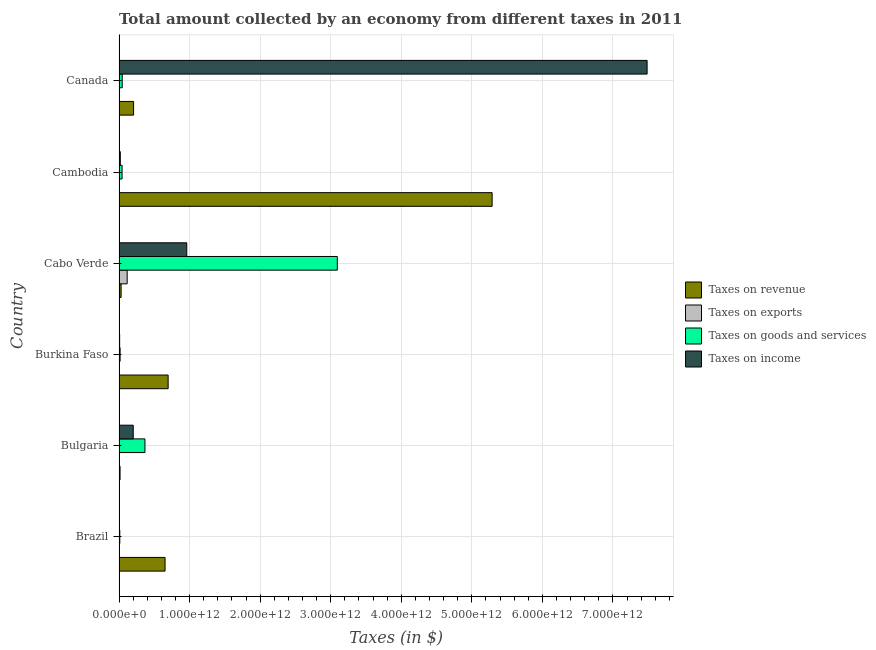How many different coloured bars are there?
Offer a terse response. 4. Are the number of bars on each tick of the Y-axis equal?
Keep it short and to the point. No. How many bars are there on the 2nd tick from the top?
Your response must be concise. 4. What is the label of the 4th group of bars from the top?
Offer a very short reply. Burkina Faso. What is the amount collected as tax on income in Bulgaria?
Your response must be concise. 2.01e+11. Across all countries, what is the maximum amount collected as tax on goods?
Give a very brief answer. 3.09e+12. Across all countries, what is the minimum amount collected as tax on goods?
Keep it short and to the point. 1.07e+1. In which country was the amount collected as tax on goods maximum?
Give a very brief answer. Cabo Verde. What is the total amount collected as tax on exports in the graph?
Keep it short and to the point. 1.18e+11. What is the difference between the amount collected as tax on exports in Bulgaria and that in Canada?
Provide a short and direct response. -7.51e+08. What is the difference between the amount collected as tax on revenue in Burkina Faso and the amount collected as tax on exports in Cabo Verde?
Ensure brevity in your answer.  5.81e+11. What is the average amount collected as tax on exports per country?
Your response must be concise. 1.97e+1. What is the difference between the amount collected as tax on income and amount collected as tax on revenue in Cabo Verde?
Offer a terse response. 9.30e+11. What is the ratio of the amount collected as tax on revenue in Brazil to that in Cambodia?
Offer a terse response. 0.12. Is the difference between the amount collected as tax on exports in Cabo Verde and Canada greater than the difference between the amount collected as tax on revenue in Cabo Verde and Canada?
Your response must be concise. Yes. What is the difference between the highest and the second highest amount collected as tax on revenue?
Offer a terse response. 4.59e+12. What is the difference between the highest and the lowest amount collected as tax on income?
Keep it short and to the point. 7.48e+12. In how many countries, is the amount collected as tax on revenue greater than the average amount collected as tax on revenue taken over all countries?
Your answer should be compact. 1. Is it the case that in every country, the sum of the amount collected as tax on revenue and amount collected as tax on exports is greater than the amount collected as tax on goods?
Your answer should be compact. No. How many bars are there?
Provide a succinct answer. 23. Are all the bars in the graph horizontal?
Keep it short and to the point. Yes. How many countries are there in the graph?
Give a very brief answer. 6. What is the difference between two consecutive major ticks on the X-axis?
Your answer should be compact. 1.00e+12. Are the values on the major ticks of X-axis written in scientific E-notation?
Give a very brief answer. Yes. Does the graph contain grids?
Make the answer very short. Yes. Where does the legend appear in the graph?
Keep it short and to the point. Center right. How many legend labels are there?
Ensure brevity in your answer.  4. How are the legend labels stacked?
Your response must be concise. Vertical. What is the title of the graph?
Your response must be concise. Total amount collected by an economy from different taxes in 2011. Does "Secondary vocational education" appear as one of the legend labels in the graph?
Your answer should be very brief. No. What is the label or title of the X-axis?
Make the answer very short. Taxes (in $). What is the Taxes (in $) of Taxes on revenue in Brazil?
Make the answer very short. 6.52e+11. What is the Taxes (in $) of Taxes on exports in Brazil?
Make the answer very short. 5.00e+06. What is the Taxes (in $) of Taxes on goods and services in Brazil?
Offer a very short reply. 1.07e+1. What is the Taxes (in $) in Taxes on income in Brazil?
Provide a short and direct response. 3.66e+09. What is the Taxes (in $) in Taxes on revenue in Bulgaria?
Give a very brief answer. 1.43e+1. What is the Taxes (in $) of Taxes on exports in Bulgaria?
Offer a terse response. 1.33e+09. What is the Taxes (in $) in Taxes on goods and services in Bulgaria?
Provide a succinct answer. 3.67e+11. What is the Taxes (in $) of Taxes on income in Bulgaria?
Your response must be concise. 2.01e+11. What is the Taxes (in $) of Taxes on revenue in Burkina Faso?
Offer a terse response. 6.96e+11. What is the Taxes (in $) in Taxes on exports in Burkina Faso?
Your answer should be very brief. 0. What is the Taxes (in $) in Taxes on goods and services in Burkina Faso?
Make the answer very short. 1.50e+1. What is the Taxes (in $) of Taxes on income in Burkina Faso?
Your answer should be very brief. 8.28e+09. What is the Taxes (in $) of Taxes on revenue in Cabo Verde?
Your answer should be very brief. 2.92e+1. What is the Taxes (in $) of Taxes on exports in Cabo Verde?
Ensure brevity in your answer.  1.15e+11. What is the Taxes (in $) in Taxes on goods and services in Cabo Verde?
Make the answer very short. 3.09e+12. What is the Taxes (in $) of Taxes on income in Cabo Verde?
Provide a short and direct response. 9.60e+11. What is the Taxes (in $) of Taxes on revenue in Cambodia?
Offer a terse response. 5.29e+12. What is the Taxes (in $) in Taxes on exports in Cambodia?
Ensure brevity in your answer.  2.67e+04. What is the Taxes (in $) in Taxes on goods and services in Cambodia?
Ensure brevity in your answer.  4.28e+1. What is the Taxes (in $) in Taxes on income in Cambodia?
Provide a short and direct response. 1.77e+1. What is the Taxes (in $) of Taxes on revenue in Canada?
Your answer should be very brief. 2.06e+11. What is the Taxes (in $) of Taxes on exports in Canada?
Offer a terse response. 2.08e+09. What is the Taxes (in $) of Taxes on goods and services in Canada?
Make the answer very short. 4.49e+1. What is the Taxes (in $) in Taxes on income in Canada?
Your answer should be compact. 7.48e+12. Across all countries, what is the maximum Taxes (in $) of Taxes on revenue?
Ensure brevity in your answer.  5.29e+12. Across all countries, what is the maximum Taxes (in $) of Taxes on exports?
Offer a very short reply. 1.15e+11. Across all countries, what is the maximum Taxes (in $) in Taxes on goods and services?
Your response must be concise. 3.09e+12. Across all countries, what is the maximum Taxes (in $) of Taxes on income?
Keep it short and to the point. 7.48e+12. Across all countries, what is the minimum Taxes (in $) in Taxes on revenue?
Your answer should be very brief. 1.43e+1. Across all countries, what is the minimum Taxes (in $) of Taxes on goods and services?
Your answer should be compact. 1.07e+1. Across all countries, what is the minimum Taxes (in $) of Taxes on income?
Make the answer very short. 3.66e+09. What is the total Taxes (in $) in Taxes on revenue in the graph?
Offer a terse response. 6.88e+12. What is the total Taxes (in $) of Taxes on exports in the graph?
Provide a succinct answer. 1.18e+11. What is the total Taxes (in $) of Taxes on goods and services in the graph?
Offer a very short reply. 3.57e+12. What is the total Taxes (in $) of Taxes on income in the graph?
Offer a very short reply. 8.67e+12. What is the difference between the Taxes (in $) in Taxes on revenue in Brazil and that in Bulgaria?
Keep it short and to the point. 6.38e+11. What is the difference between the Taxes (in $) in Taxes on exports in Brazil and that in Bulgaria?
Your answer should be compact. -1.32e+09. What is the difference between the Taxes (in $) in Taxes on goods and services in Brazil and that in Bulgaria?
Your answer should be very brief. -3.56e+11. What is the difference between the Taxes (in $) in Taxes on income in Brazil and that in Bulgaria?
Your response must be concise. -1.97e+11. What is the difference between the Taxes (in $) of Taxes on revenue in Brazil and that in Burkina Faso?
Offer a very short reply. -4.36e+1. What is the difference between the Taxes (in $) of Taxes on goods and services in Brazil and that in Burkina Faso?
Your response must be concise. -4.31e+09. What is the difference between the Taxes (in $) of Taxes on income in Brazil and that in Burkina Faso?
Offer a terse response. -4.63e+09. What is the difference between the Taxes (in $) of Taxes on revenue in Brazil and that in Cabo Verde?
Offer a terse response. 6.23e+11. What is the difference between the Taxes (in $) of Taxes on exports in Brazil and that in Cabo Verde?
Your answer should be compact. -1.15e+11. What is the difference between the Taxes (in $) of Taxes on goods and services in Brazil and that in Cabo Verde?
Your answer should be very brief. -3.08e+12. What is the difference between the Taxes (in $) of Taxes on income in Brazil and that in Cabo Verde?
Make the answer very short. -9.56e+11. What is the difference between the Taxes (in $) in Taxes on revenue in Brazil and that in Cambodia?
Ensure brevity in your answer.  -4.64e+12. What is the difference between the Taxes (in $) in Taxes on exports in Brazil and that in Cambodia?
Make the answer very short. 4.97e+06. What is the difference between the Taxes (in $) in Taxes on goods and services in Brazil and that in Cambodia?
Make the answer very short. -3.22e+1. What is the difference between the Taxes (in $) in Taxes on income in Brazil and that in Cambodia?
Your answer should be very brief. -1.40e+1. What is the difference between the Taxes (in $) in Taxes on revenue in Brazil and that in Canada?
Ensure brevity in your answer.  4.46e+11. What is the difference between the Taxes (in $) in Taxes on exports in Brazil and that in Canada?
Your answer should be very brief. -2.08e+09. What is the difference between the Taxes (in $) of Taxes on goods and services in Brazil and that in Canada?
Make the answer very short. -3.42e+1. What is the difference between the Taxes (in $) in Taxes on income in Brazil and that in Canada?
Ensure brevity in your answer.  -7.48e+12. What is the difference between the Taxes (in $) in Taxes on revenue in Bulgaria and that in Burkina Faso?
Offer a very short reply. -6.81e+11. What is the difference between the Taxes (in $) in Taxes on goods and services in Bulgaria and that in Burkina Faso?
Your answer should be very brief. 3.52e+11. What is the difference between the Taxes (in $) in Taxes on income in Bulgaria and that in Burkina Faso?
Provide a succinct answer. 1.93e+11. What is the difference between the Taxes (in $) in Taxes on revenue in Bulgaria and that in Cabo Verde?
Provide a succinct answer. -1.48e+1. What is the difference between the Taxes (in $) of Taxes on exports in Bulgaria and that in Cabo Verde?
Your answer should be compact. -1.14e+11. What is the difference between the Taxes (in $) of Taxes on goods and services in Bulgaria and that in Cabo Verde?
Your answer should be compact. -2.73e+12. What is the difference between the Taxes (in $) of Taxes on income in Bulgaria and that in Cabo Verde?
Provide a short and direct response. -7.59e+11. What is the difference between the Taxes (in $) of Taxes on revenue in Bulgaria and that in Cambodia?
Keep it short and to the point. -5.27e+12. What is the difference between the Taxes (in $) of Taxes on exports in Bulgaria and that in Cambodia?
Provide a succinct answer. 1.33e+09. What is the difference between the Taxes (in $) of Taxes on goods and services in Bulgaria and that in Cambodia?
Provide a short and direct response. 3.24e+11. What is the difference between the Taxes (in $) in Taxes on income in Bulgaria and that in Cambodia?
Make the answer very short. 1.83e+11. What is the difference between the Taxes (in $) of Taxes on revenue in Bulgaria and that in Canada?
Give a very brief answer. -1.92e+11. What is the difference between the Taxes (in $) of Taxes on exports in Bulgaria and that in Canada?
Your answer should be very brief. -7.51e+08. What is the difference between the Taxes (in $) of Taxes on goods and services in Bulgaria and that in Canada?
Provide a succinct answer. 3.22e+11. What is the difference between the Taxes (in $) in Taxes on income in Bulgaria and that in Canada?
Your answer should be compact. -7.28e+12. What is the difference between the Taxes (in $) in Taxes on revenue in Burkina Faso and that in Cabo Verde?
Ensure brevity in your answer.  6.66e+11. What is the difference between the Taxes (in $) in Taxes on goods and services in Burkina Faso and that in Cabo Verde?
Make the answer very short. -3.08e+12. What is the difference between the Taxes (in $) in Taxes on income in Burkina Faso and that in Cabo Verde?
Provide a short and direct response. -9.51e+11. What is the difference between the Taxes (in $) of Taxes on revenue in Burkina Faso and that in Cambodia?
Give a very brief answer. -4.59e+12. What is the difference between the Taxes (in $) of Taxes on goods and services in Burkina Faso and that in Cambodia?
Provide a succinct answer. -2.79e+1. What is the difference between the Taxes (in $) of Taxes on income in Burkina Faso and that in Cambodia?
Your answer should be compact. -9.39e+09. What is the difference between the Taxes (in $) of Taxes on revenue in Burkina Faso and that in Canada?
Keep it short and to the point. 4.89e+11. What is the difference between the Taxes (in $) of Taxes on goods and services in Burkina Faso and that in Canada?
Give a very brief answer. -2.99e+1. What is the difference between the Taxes (in $) in Taxes on income in Burkina Faso and that in Canada?
Offer a terse response. -7.48e+12. What is the difference between the Taxes (in $) of Taxes on revenue in Cabo Verde and that in Cambodia?
Your answer should be compact. -5.26e+12. What is the difference between the Taxes (in $) in Taxes on exports in Cabo Verde and that in Cambodia?
Give a very brief answer. 1.15e+11. What is the difference between the Taxes (in $) of Taxes on goods and services in Cabo Verde and that in Cambodia?
Your answer should be very brief. 3.05e+12. What is the difference between the Taxes (in $) in Taxes on income in Cabo Verde and that in Cambodia?
Keep it short and to the point. 9.42e+11. What is the difference between the Taxes (in $) in Taxes on revenue in Cabo Verde and that in Canada?
Your response must be concise. -1.77e+11. What is the difference between the Taxes (in $) in Taxes on exports in Cabo Verde and that in Canada?
Provide a succinct answer. 1.13e+11. What is the difference between the Taxes (in $) of Taxes on goods and services in Cabo Verde and that in Canada?
Your answer should be compact. 3.05e+12. What is the difference between the Taxes (in $) in Taxes on income in Cabo Verde and that in Canada?
Keep it short and to the point. -6.52e+12. What is the difference between the Taxes (in $) in Taxes on revenue in Cambodia and that in Canada?
Give a very brief answer. 5.08e+12. What is the difference between the Taxes (in $) of Taxes on exports in Cambodia and that in Canada?
Provide a short and direct response. -2.08e+09. What is the difference between the Taxes (in $) of Taxes on goods and services in Cambodia and that in Canada?
Your answer should be compact. -2.03e+09. What is the difference between the Taxes (in $) in Taxes on income in Cambodia and that in Canada?
Offer a terse response. -7.47e+12. What is the difference between the Taxes (in $) of Taxes on revenue in Brazil and the Taxes (in $) of Taxes on exports in Bulgaria?
Ensure brevity in your answer.  6.51e+11. What is the difference between the Taxes (in $) of Taxes on revenue in Brazil and the Taxes (in $) of Taxes on goods and services in Bulgaria?
Your answer should be very brief. 2.85e+11. What is the difference between the Taxes (in $) of Taxes on revenue in Brazil and the Taxes (in $) of Taxes on income in Bulgaria?
Provide a short and direct response. 4.51e+11. What is the difference between the Taxes (in $) in Taxes on exports in Brazil and the Taxes (in $) in Taxes on goods and services in Bulgaria?
Offer a very short reply. -3.67e+11. What is the difference between the Taxes (in $) in Taxes on exports in Brazil and the Taxes (in $) in Taxes on income in Bulgaria?
Your answer should be compact. -2.01e+11. What is the difference between the Taxes (in $) of Taxes on goods and services in Brazil and the Taxes (in $) of Taxes on income in Bulgaria?
Ensure brevity in your answer.  -1.90e+11. What is the difference between the Taxes (in $) of Taxes on revenue in Brazil and the Taxes (in $) of Taxes on goods and services in Burkina Faso?
Offer a very short reply. 6.37e+11. What is the difference between the Taxes (in $) of Taxes on revenue in Brazil and the Taxes (in $) of Taxes on income in Burkina Faso?
Give a very brief answer. 6.44e+11. What is the difference between the Taxes (in $) of Taxes on exports in Brazil and the Taxes (in $) of Taxes on goods and services in Burkina Faso?
Offer a terse response. -1.50e+1. What is the difference between the Taxes (in $) of Taxes on exports in Brazil and the Taxes (in $) of Taxes on income in Burkina Faso?
Your response must be concise. -8.28e+09. What is the difference between the Taxes (in $) in Taxes on goods and services in Brazil and the Taxes (in $) in Taxes on income in Burkina Faso?
Keep it short and to the point. 2.37e+09. What is the difference between the Taxes (in $) in Taxes on revenue in Brazil and the Taxes (in $) in Taxes on exports in Cabo Verde?
Your answer should be compact. 5.37e+11. What is the difference between the Taxes (in $) of Taxes on revenue in Brazil and the Taxes (in $) of Taxes on goods and services in Cabo Verde?
Make the answer very short. -2.44e+12. What is the difference between the Taxes (in $) in Taxes on revenue in Brazil and the Taxes (in $) in Taxes on income in Cabo Verde?
Your answer should be compact. -3.08e+11. What is the difference between the Taxes (in $) of Taxes on exports in Brazil and the Taxes (in $) of Taxes on goods and services in Cabo Verde?
Your answer should be compact. -3.09e+12. What is the difference between the Taxes (in $) of Taxes on exports in Brazil and the Taxes (in $) of Taxes on income in Cabo Verde?
Your response must be concise. -9.60e+11. What is the difference between the Taxes (in $) in Taxes on goods and services in Brazil and the Taxes (in $) in Taxes on income in Cabo Verde?
Your answer should be compact. -9.49e+11. What is the difference between the Taxes (in $) of Taxes on revenue in Brazil and the Taxes (in $) of Taxes on exports in Cambodia?
Offer a terse response. 6.52e+11. What is the difference between the Taxes (in $) of Taxes on revenue in Brazil and the Taxes (in $) of Taxes on goods and services in Cambodia?
Ensure brevity in your answer.  6.09e+11. What is the difference between the Taxes (in $) of Taxes on revenue in Brazil and the Taxes (in $) of Taxes on income in Cambodia?
Provide a succinct answer. 6.34e+11. What is the difference between the Taxes (in $) in Taxes on exports in Brazil and the Taxes (in $) in Taxes on goods and services in Cambodia?
Offer a terse response. -4.28e+1. What is the difference between the Taxes (in $) of Taxes on exports in Brazil and the Taxes (in $) of Taxes on income in Cambodia?
Make the answer very short. -1.77e+1. What is the difference between the Taxes (in $) in Taxes on goods and services in Brazil and the Taxes (in $) in Taxes on income in Cambodia?
Your answer should be very brief. -7.03e+09. What is the difference between the Taxes (in $) of Taxes on revenue in Brazil and the Taxes (in $) of Taxes on exports in Canada?
Make the answer very short. 6.50e+11. What is the difference between the Taxes (in $) in Taxes on revenue in Brazil and the Taxes (in $) in Taxes on goods and services in Canada?
Offer a very short reply. 6.07e+11. What is the difference between the Taxes (in $) of Taxes on revenue in Brazil and the Taxes (in $) of Taxes on income in Canada?
Ensure brevity in your answer.  -6.83e+12. What is the difference between the Taxes (in $) in Taxes on exports in Brazil and the Taxes (in $) in Taxes on goods and services in Canada?
Offer a very short reply. -4.49e+1. What is the difference between the Taxes (in $) in Taxes on exports in Brazil and the Taxes (in $) in Taxes on income in Canada?
Make the answer very short. -7.48e+12. What is the difference between the Taxes (in $) in Taxes on goods and services in Brazil and the Taxes (in $) in Taxes on income in Canada?
Offer a terse response. -7.47e+12. What is the difference between the Taxes (in $) of Taxes on revenue in Bulgaria and the Taxes (in $) of Taxes on goods and services in Burkina Faso?
Your answer should be compact. -6.16e+08. What is the difference between the Taxes (in $) of Taxes on revenue in Bulgaria and the Taxes (in $) of Taxes on income in Burkina Faso?
Make the answer very short. 6.06e+09. What is the difference between the Taxes (in $) of Taxes on exports in Bulgaria and the Taxes (in $) of Taxes on goods and services in Burkina Faso?
Offer a terse response. -1.36e+1. What is the difference between the Taxes (in $) in Taxes on exports in Bulgaria and the Taxes (in $) in Taxes on income in Burkina Faso?
Your answer should be very brief. -6.95e+09. What is the difference between the Taxes (in $) of Taxes on goods and services in Bulgaria and the Taxes (in $) of Taxes on income in Burkina Faso?
Offer a terse response. 3.58e+11. What is the difference between the Taxes (in $) of Taxes on revenue in Bulgaria and the Taxes (in $) of Taxes on exports in Cabo Verde?
Your response must be concise. -1.01e+11. What is the difference between the Taxes (in $) in Taxes on revenue in Bulgaria and the Taxes (in $) in Taxes on goods and services in Cabo Verde?
Provide a short and direct response. -3.08e+12. What is the difference between the Taxes (in $) of Taxes on revenue in Bulgaria and the Taxes (in $) of Taxes on income in Cabo Verde?
Provide a short and direct response. -9.45e+11. What is the difference between the Taxes (in $) of Taxes on exports in Bulgaria and the Taxes (in $) of Taxes on goods and services in Cabo Verde?
Ensure brevity in your answer.  -3.09e+12. What is the difference between the Taxes (in $) of Taxes on exports in Bulgaria and the Taxes (in $) of Taxes on income in Cabo Verde?
Keep it short and to the point. -9.58e+11. What is the difference between the Taxes (in $) of Taxes on goods and services in Bulgaria and the Taxes (in $) of Taxes on income in Cabo Verde?
Keep it short and to the point. -5.93e+11. What is the difference between the Taxes (in $) of Taxes on revenue in Bulgaria and the Taxes (in $) of Taxes on exports in Cambodia?
Provide a short and direct response. 1.43e+1. What is the difference between the Taxes (in $) of Taxes on revenue in Bulgaria and the Taxes (in $) of Taxes on goods and services in Cambodia?
Provide a succinct answer. -2.85e+1. What is the difference between the Taxes (in $) in Taxes on revenue in Bulgaria and the Taxes (in $) in Taxes on income in Cambodia?
Your response must be concise. -3.33e+09. What is the difference between the Taxes (in $) of Taxes on exports in Bulgaria and the Taxes (in $) of Taxes on goods and services in Cambodia?
Your response must be concise. -4.15e+1. What is the difference between the Taxes (in $) of Taxes on exports in Bulgaria and the Taxes (in $) of Taxes on income in Cambodia?
Provide a succinct answer. -1.63e+1. What is the difference between the Taxes (in $) in Taxes on goods and services in Bulgaria and the Taxes (in $) in Taxes on income in Cambodia?
Ensure brevity in your answer.  3.49e+11. What is the difference between the Taxes (in $) in Taxes on revenue in Bulgaria and the Taxes (in $) in Taxes on exports in Canada?
Offer a very short reply. 1.23e+1. What is the difference between the Taxes (in $) in Taxes on revenue in Bulgaria and the Taxes (in $) in Taxes on goods and services in Canada?
Keep it short and to the point. -3.05e+1. What is the difference between the Taxes (in $) in Taxes on revenue in Bulgaria and the Taxes (in $) in Taxes on income in Canada?
Make the answer very short. -7.47e+12. What is the difference between the Taxes (in $) of Taxes on exports in Bulgaria and the Taxes (in $) of Taxes on goods and services in Canada?
Offer a terse response. -4.35e+1. What is the difference between the Taxes (in $) of Taxes on exports in Bulgaria and the Taxes (in $) of Taxes on income in Canada?
Your answer should be compact. -7.48e+12. What is the difference between the Taxes (in $) in Taxes on goods and services in Bulgaria and the Taxes (in $) in Taxes on income in Canada?
Your answer should be very brief. -7.12e+12. What is the difference between the Taxes (in $) of Taxes on revenue in Burkina Faso and the Taxes (in $) of Taxes on exports in Cabo Verde?
Make the answer very short. 5.81e+11. What is the difference between the Taxes (in $) of Taxes on revenue in Burkina Faso and the Taxes (in $) of Taxes on goods and services in Cabo Verde?
Your answer should be very brief. -2.40e+12. What is the difference between the Taxes (in $) of Taxes on revenue in Burkina Faso and the Taxes (in $) of Taxes on income in Cabo Verde?
Offer a terse response. -2.64e+11. What is the difference between the Taxes (in $) of Taxes on goods and services in Burkina Faso and the Taxes (in $) of Taxes on income in Cabo Verde?
Offer a terse response. -9.45e+11. What is the difference between the Taxes (in $) in Taxes on revenue in Burkina Faso and the Taxes (in $) in Taxes on exports in Cambodia?
Make the answer very short. 6.96e+11. What is the difference between the Taxes (in $) of Taxes on revenue in Burkina Faso and the Taxes (in $) of Taxes on goods and services in Cambodia?
Make the answer very short. 6.53e+11. What is the difference between the Taxes (in $) in Taxes on revenue in Burkina Faso and the Taxes (in $) in Taxes on income in Cambodia?
Offer a terse response. 6.78e+11. What is the difference between the Taxes (in $) of Taxes on goods and services in Burkina Faso and the Taxes (in $) of Taxes on income in Cambodia?
Give a very brief answer. -2.71e+09. What is the difference between the Taxes (in $) of Taxes on revenue in Burkina Faso and the Taxes (in $) of Taxes on exports in Canada?
Give a very brief answer. 6.94e+11. What is the difference between the Taxes (in $) of Taxes on revenue in Burkina Faso and the Taxes (in $) of Taxes on goods and services in Canada?
Provide a short and direct response. 6.51e+11. What is the difference between the Taxes (in $) of Taxes on revenue in Burkina Faso and the Taxes (in $) of Taxes on income in Canada?
Your answer should be very brief. -6.79e+12. What is the difference between the Taxes (in $) of Taxes on goods and services in Burkina Faso and the Taxes (in $) of Taxes on income in Canada?
Ensure brevity in your answer.  -7.47e+12. What is the difference between the Taxes (in $) of Taxes on revenue in Cabo Verde and the Taxes (in $) of Taxes on exports in Cambodia?
Offer a terse response. 2.92e+1. What is the difference between the Taxes (in $) of Taxes on revenue in Cabo Verde and the Taxes (in $) of Taxes on goods and services in Cambodia?
Provide a short and direct response. -1.37e+1. What is the difference between the Taxes (in $) in Taxes on revenue in Cabo Verde and the Taxes (in $) in Taxes on income in Cambodia?
Make the answer very short. 1.15e+1. What is the difference between the Taxes (in $) of Taxes on exports in Cabo Verde and the Taxes (in $) of Taxes on goods and services in Cambodia?
Your response must be concise. 7.22e+1. What is the difference between the Taxes (in $) of Taxes on exports in Cabo Verde and the Taxes (in $) of Taxes on income in Cambodia?
Provide a succinct answer. 9.74e+1. What is the difference between the Taxes (in $) of Taxes on goods and services in Cabo Verde and the Taxes (in $) of Taxes on income in Cambodia?
Your answer should be very brief. 3.08e+12. What is the difference between the Taxes (in $) of Taxes on revenue in Cabo Verde and the Taxes (in $) of Taxes on exports in Canada?
Ensure brevity in your answer.  2.71e+1. What is the difference between the Taxes (in $) of Taxes on revenue in Cabo Verde and the Taxes (in $) of Taxes on goods and services in Canada?
Make the answer very short. -1.57e+1. What is the difference between the Taxes (in $) of Taxes on revenue in Cabo Verde and the Taxes (in $) of Taxes on income in Canada?
Keep it short and to the point. -7.45e+12. What is the difference between the Taxes (in $) in Taxes on exports in Cabo Verde and the Taxes (in $) in Taxes on goods and services in Canada?
Provide a short and direct response. 7.02e+1. What is the difference between the Taxes (in $) of Taxes on exports in Cabo Verde and the Taxes (in $) of Taxes on income in Canada?
Offer a terse response. -7.37e+12. What is the difference between the Taxes (in $) of Taxes on goods and services in Cabo Verde and the Taxes (in $) of Taxes on income in Canada?
Your answer should be very brief. -4.39e+12. What is the difference between the Taxes (in $) of Taxes on revenue in Cambodia and the Taxes (in $) of Taxes on exports in Canada?
Give a very brief answer. 5.29e+12. What is the difference between the Taxes (in $) in Taxes on revenue in Cambodia and the Taxes (in $) in Taxes on goods and services in Canada?
Your response must be concise. 5.24e+12. What is the difference between the Taxes (in $) in Taxes on revenue in Cambodia and the Taxes (in $) in Taxes on income in Canada?
Give a very brief answer. -2.20e+12. What is the difference between the Taxes (in $) in Taxes on exports in Cambodia and the Taxes (in $) in Taxes on goods and services in Canada?
Provide a succinct answer. -4.49e+1. What is the difference between the Taxes (in $) in Taxes on exports in Cambodia and the Taxes (in $) in Taxes on income in Canada?
Your answer should be compact. -7.48e+12. What is the difference between the Taxes (in $) in Taxes on goods and services in Cambodia and the Taxes (in $) in Taxes on income in Canada?
Your answer should be very brief. -7.44e+12. What is the average Taxes (in $) of Taxes on revenue per country?
Your answer should be compact. 1.15e+12. What is the average Taxes (in $) of Taxes on exports per country?
Your response must be concise. 1.97e+1. What is the average Taxes (in $) in Taxes on goods and services per country?
Your answer should be very brief. 5.96e+11. What is the average Taxes (in $) in Taxes on income per country?
Your response must be concise. 1.45e+12. What is the difference between the Taxes (in $) of Taxes on revenue and Taxes (in $) of Taxes on exports in Brazil?
Your response must be concise. 6.52e+11. What is the difference between the Taxes (in $) in Taxes on revenue and Taxes (in $) in Taxes on goods and services in Brazil?
Your answer should be very brief. 6.41e+11. What is the difference between the Taxes (in $) in Taxes on revenue and Taxes (in $) in Taxes on income in Brazil?
Offer a terse response. 6.48e+11. What is the difference between the Taxes (in $) in Taxes on exports and Taxes (in $) in Taxes on goods and services in Brazil?
Your answer should be very brief. -1.06e+1. What is the difference between the Taxes (in $) of Taxes on exports and Taxes (in $) of Taxes on income in Brazil?
Give a very brief answer. -3.65e+09. What is the difference between the Taxes (in $) in Taxes on goods and services and Taxes (in $) in Taxes on income in Brazil?
Provide a succinct answer. 6.99e+09. What is the difference between the Taxes (in $) of Taxes on revenue and Taxes (in $) of Taxes on exports in Bulgaria?
Your answer should be very brief. 1.30e+1. What is the difference between the Taxes (in $) of Taxes on revenue and Taxes (in $) of Taxes on goods and services in Bulgaria?
Ensure brevity in your answer.  -3.52e+11. What is the difference between the Taxes (in $) in Taxes on revenue and Taxes (in $) in Taxes on income in Bulgaria?
Give a very brief answer. -1.87e+11. What is the difference between the Taxes (in $) of Taxes on exports and Taxes (in $) of Taxes on goods and services in Bulgaria?
Your answer should be very brief. -3.65e+11. What is the difference between the Taxes (in $) in Taxes on exports and Taxes (in $) in Taxes on income in Bulgaria?
Ensure brevity in your answer.  -2.00e+11. What is the difference between the Taxes (in $) in Taxes on goods and services and Taxes (in $) in Taxes on income in Bulgaria?
Ensure brevity in your answer.  1.66e+11. What is the difference between the Taxes (in $) in Taxes on revenue and Taxes (in $) in Taxes on goods and services in Burkina Faso?
Offer a very short reply. 6.81e+11. What is the difference between the Taxes (in $) in Taxes on revenue and Taxes (in $) in Taxes on income in Burkina Faso?
Your answer should be compact. 6.87e+11. What is the difference between the Taxes (in $) in Taxes on goods and services and Taxes (in $) in Taxes on income in Burkina Faso?
Your response must be concise. 6.68e+09. What is the difference between the Taxes (in $) of Taxes on revenue and Taxes (in $) of Taxes on exports in Cabo Verde?
Ensure brevity in your answer.  -8.59e+1. What is the difference between the Taxes (in $) in Taxes on revenue and Taxes (in $) in Taxes on goods and services in Cabo Verde?
Offer a very short reply. -3.06e+12. What is the difference between the Taxes (in $) in Taxes on revenue and Taxes (in $) in Taxes on income in Cabo Verde?
Keep it short and to the point. -9.30e+11. What is the difference between the Taxes (in $) of Taxes on exports and Taxes (in $) of Taxes on goods and services in Cabo Verde?
Give a very brief answer. -2.98e+12. What is the difference between the Taxes (in $) in Taxes on exports and Taxes (in $) in Taxes on income in Cabo Verde?
Provide a short and direct response. -8.45e+11. What is the difference between the Taxes (in $) in Taxes on goods and services and Taxes (in $) in Taxes on income in Cabo Verde?
Offer a terse response. 2.13e+12. What is the difference between the Taxes (in $) of Taxes on revenue and Taxes (in $) of Taxes on exports in Cambodia?
Ensure brevity in your answer.  5.29e+12. What is the difference between the Taxes (in $) of Taxes on revenue and Taxes (in $) of Taxes on goods and services in Cambodia?
Offer a terse response. 5.24e+12. What is the difference between the Taxes (in $) of Taxes on revenue and Taxes (in $) of Taxes on income in Cambodia?
Provide a short and direct response. 5.27e+12. What is the difference between the Taxes (in $) of Taxes on exports and Taxes (in $) of Taxes on goods and services in Cambodia?
Give a very brief answer. -4.28e+1. What is the difference between the Taxes (in $) in Taxes on exports and Taxes (in $) in Taxes on income in Cambodia?
Provide a succinct answer. -1.77e+1. What is the difference between the Taxes (in $) of Taxes on goods and services and Taxes (in $) of Taxes on income in Cambodia?
Your answer should be very brief. 2.52e+1. What is the difference between the Taxes (in $) of Taxes on revenue and Taxes (in $) of Taxes on exports in Canada?
Your answer should be very brief. 2.04e+11. What is the difference between the Taxes (in $) of Taxes on revenue and Taxes (in $) of Taxes on goods and services in Canada?
Give a very brief answer. 1.61e+11. What is the difference between the Taxes (in $) of Taxes on revenue and Taxes (in $) of Taxes on income in Canada?
Provide a short and direct response. -7.28e+12. What is the difference between the Taxes (in $) in Taxes on exports and Taxes (in $) in Taxes on goods and services in Canada?
Keep it short and to the point. -4.28e+1. What is the difference between the Taxes (in $) of Taxes on exports and Taxes (in $) of Taxes on income in Canada?
Your answer should be very brief. -7.48e+12. What is the difference between the Taxes (in $) in Taxes on goods and services and Taxes (in $) in Taxes on income in Canada?
Keep it short and to the point. -7.44e+12. What is the ratio of the Taxes (in $) of Taxes on revenue in Brazil to that in Bulgaria?
Offer a terse response. 45.44. What is the ratio of the Taxes (in $) of Taxes on exports in Brazil to that in Bulgaria?
Offer a very short reply. 0. What is the ratio of the Taxes (in $) in Taxes on goods and services in Brazil to that in Bulgaria?
Your answer should be compact. 0.03. What is the ratio of the Taxes (in $) of Taxes on income in Brazil to that in Bulgaria?
Ensure brevity in your answer.  0.02. What is the ratio of the Taxes (in $) in Taxes on revenue in Brazil to that in Burkina Faso?
Provide a short and direct response. 0.94. What is the ratio of the Taxes (in $) of Taxes on goods and services in Brazil to that in Burkina Faso?
Provide a short and direct response. 0.71. What is the ratio of the Taxes (in $) of Taxes on income in Brazil to that in Burkina Faso?
Make the answer very short. 0.44. What is the ratio of the Taxes (in $) in Taxes on revenue in Brazil to that in Cabo Verde?
Your answer should be compact. 22.34. What is the ratio of the Taxes (in $) of Taxes on exports in Brazil to that in Cabo Verde?
Make the answer very short. 0. What is the ratio of the Taxes (in $) of Taxes on goods and services in Brazil to that in Cabo Verde?
Provide a succinct answer. 0. What is the ratio of the Taxes (in $) in Taxes on income in Brazil to that in Cabo Verde?
Your answer should be compact. 0. What is the ratio of the Taxes (in $) in Taxes on revenue in Brazil to that in Cambodia?
Your answer should be very brief. 0.12. What is the ratio of the Taxes (in $) in Taxes on exports in Brazil to that in Cambodia?
Ensure brevity in your answer.  187.59. What is the ratio of the Taxes (in $) of Taxes on goods and services in Brazil to that in Cambodia?
Offer a very short reply. 0.25. What is the ratio of the Taxes (in $) of Taxes on income in Brazil to that in Cambodia?
Your answer should be compact. 0.21. What is the ratio of the Taxes (in $) in Taxes on revenue in Brazil to that in Canada?
Offer a very short reply. 3.16. What is the ratio of the Taxes (in $) in Taxes on exports in Brazil to that in Canada?
Your response must be concise. 0. What is the ratio of the Taxes (in $) in Taxes on goods and services in Brazil to that in Canada?
Provide a short and direct response. 0.24. What is the ratio of the Taxes (in $) in Taxes on revenue in Bulgaria to that in Burkina Faso?
Ensure brevity in your answer.  0.02. What is the ratio of the Taxes (in $) in Taxes on goods and services in Bulgaria to that in Burkina Faso?
Offer a terse response. 24.51. What is the ratio of the Taxes (in $) in Taxes on income in Bulgaria to that in Burkina Faso?
Provide a succinct answer. 24.26. What is the ratio of the Taxes (in $) of Taxes on revenue in Bulgaria to that in Cabo Verde?
Make the answer very short. 0.49. What is the ratio of the Taxes (in $) in Taxes on exports in Bulgaria to that in Cabo Verde?
Your answer should be very brief. 0.01. What is the ratio of the Taxes (in $) in Taxes on goods and services in Bulgaria to that in Cabo Verde?
Give a very brief answer. 0.12. What is the ratio of the Taxes (in $) of Taxes on income in Bulgaria to that in Cabo Verde?
Your response must be concise. 0.21. What is the ratio of the Taxes (in $) of Taxes on revenue in Bulgaria to that in Cambodia?
Your answer should be very brief. 0. What is the ratio of the Taxes (in $) of Taxes on exports in Bulgaria to that in Cambodia?
Provide a succinct answer. 4.99e+04. What is the ratio of the Taxes (in $) in Taxes on goods and services in Bulgaria to that in Cambodia?
Your answer should be compact. 8.56. What is the ratio of the Taxes (in $) in Taxes on income in Bulgaria to that in Cambodia?
Your answer should be very brief. 11.37. What is the ratio of the Taxes (in $) of Taxes on revenue in Bulgaria to that in Canada?
Keep it short and to the point. 0.07. What is the ratio of the Taxes (in $) in Taxes on exports in Bulgaria to that in Canada?
Your answer should be compact. 0.64. What is the ratio of the Taxes (in $) in Taxes on goods and services in Bulgaria to that in Canada?
Provide a succinct answer. 8.17. What is the ratio of the Taxes (in $) in Taxes on income in Bulgaria to that in Canada?
Make the answer very short. 0.03. What is the ratio of the Taxes (in $) of Taxes on revenue in Burkina Faso to that in Cabo Verde?
Provide a succinct answer. 23.83. What is the ratio of the Taxes (in $) in Taxes on goods and services in Burkina Faso to that in Cabo Verde?
Your answer should be compact. 0. What is the ratio of the Taxes (in $) of Taxes on income in Burkina Faso to that in Cabo Verde?
Your answer should be compact. 0.01. What is the ratio of the Taxes (in $) of Taxes on revenue in Burkina Faso to that in Cambodia?
Offer a terse response. 0.13. What is the ratio of the Taxes (in $) of Taxes on goods and services in Burkina Faso to that in Cambodia?
Keep it short and to the point. 0.35. What is the ratio of the Taxes (in $) of Taxes on income in Burkina Faso to that in Cambodia?
Provide a succinct answer. 0.47. What is the ratio of the Taxes (in $) in Taxes on revenue in Burkina Faso to that in Canada?
Offer a terse response. 3.37. What is the ratio of the Taxes (in $) in Taxes on goods and services in Burkina Faso to that in Canada?
Provide a short and direct response. 0.33. What is the ratio of the Taxes (in $) of Taxes on income in Burkina Faso to that in Canada?
Make the answer very short. 0. What is the ratio of the Taxes (in $) in Taxes on revenue in Cabo Verde to that in Cambodia?
Make the answer very short. 0.01. What is the ratio of the Taxes (in $) in Taxes on exports in Cabo Verde to that in Cambodia?
Provide a succinct answer. 4.32e+06. What is the ratio of the Taxes (in $) in Taxes on goods and services in Cabo Verde to that in Cambodia?
Offer a terse response. 72.2. What is the ratio of the Taxes (in $) in Taxes on income in Cabo Verde to that in Cambodia?
Ensure brevity in your answer.  54.28. What is the ratio of the Taxes (in $) of Taxes on revenue in Cabo Verde to that in Canada?
Your answer should be compact. 0.14. What is the ratio of the Taxes (in $) of Taxes on exports in Cabo Verde to that in Canada?
Make the answer very short. 55.3. What is the ratio of the Taxes (in $) of Taxes on goods and services in Cabo Verde to that in Canada?
Give a very brief answer. 68.94. What is the ratio of the Taxes (in $) of Taxes on income in Cabo Verde to that in Canada?
Make the answer very short. 0.13. What is the ratio of the Taxes (in $) of Taxes on revenue in Cambodia to that in Canada?
Ensure brevity in your answer.  25.64. What is the ratio of the Taxes (in $) of Taxes on goods and services in Cambodia to that in Canada?
Provide a succinct answer. 0.95. What is the ratio of the Taxes (in $) in Taxes on income in Cambodia to that in Canada?
Keep it short and to the point. 0. What is the difference between the highest and the second highest Taxes (in $) in Taxes on revenue?
Offer a very short reply. 4.59e+12. What is the difference between the highest and the second highest Taxes (in $) in Taxes on exports?
Ensure brevity in your answer.  1.13e+11. What is the difference between the highest and the second highest Taxes (in $) in Taxes on goods and services?
Provide a short and direct response. 2.73e+12. What is the difference between the highest and the second highest Taxes (in $) of Taxes on income?
Provide a short and direct response. 6.52e+12. What is the difference between the highest and the lowest Taxes (in $) in Taxes on revenue?
Your answer should be compact. 5.27e+12. What is the difference between the highest and the lowest Taxes (in $) of Taxes on exports?
Offer a terse response. 1.15e+11. What is the difference between the highest and the lowest Taxes (in $) of Taxes on goods and services?
Your response must be concise. 3.08e+12. What is the difference between the highest and the lowest Taxes (in $) of Taxes on income?
Your answer should be very brief. 7.48e+12. 